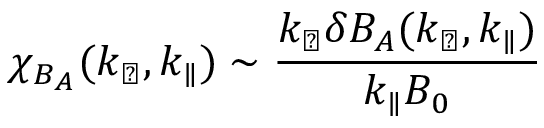<formula> <loc_0><loc_0><loc_500><loc_500>\chi _ { B _ { A } } ( k _ { \perp } , k _ { \| } ) \sim \frac { k _ { \perp } \delta B _ { A } ( k _ { \perp } , k _ { \| } ) } { k _ { \| } B _ { 0 } }</formula> 